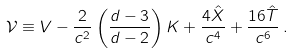Convert formula to latex. <formula><loc_0><loc_0><loc_500><loc_500>\mathcal { V } \equiv V - \frac { 2 } { c ^ { 2 } } \left ( \frac { d - 3 } { d - 2 } \right ) K + \frac { 4 \hat { X } } { c ^ { 4 } } + \frac { 1 6 \hat { T } } { c ^ { 6 } } \, .</formula> 